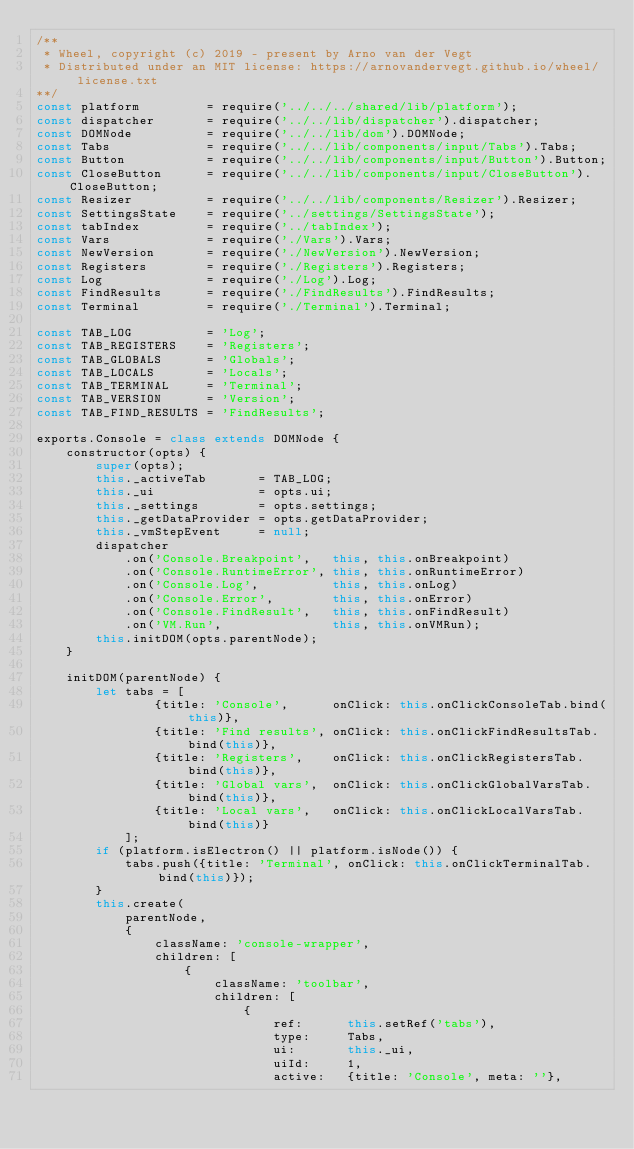<code> <loc_0><loc_0><loc_500><loc_500><_JavaScript_>/**
 * Wheel, copyright (c) 2019 - present by Arno van der Vegt
 * Distributed under an MIT license: https://arnovandervegt.github.io/wheel/license.txt
**/
const platform         = require('../../../shared/lib/platform');
const dispatcher       = require('../../lib/dispatcher').dispatcher;
const DOMNode          = require('../../lib/dom').DOMNode;
const Tabs             = require('../../lib/components/input/Tabs').Tabs;
const Button           = require('../../lib/components/input/Button').Button;
const CloseButton      = require('../../lib/components/input/CloseButton').CloseButton;
const Resizer          = require('../../lib/components/Resizer').Resizer;
const SettingsState    = require('../settings/SettingsState');
const tabIndex         = require('../tabIndex');
const Vars             = require('./Vars').Vars;
const NewVersion       = require('./NewVersion').NewVersion;
const Registers        = require('./Registers').Registers;
const Log              = require('./Log').Log;
const FindResults      = require('./FindResults').FindResults;
const Terminal         = require('./Terminal').Terminal;

const TAB_LOG          = 'Log';
const TAB_REGISTERS    = 'Registers';
const TAB_GLOBALS      = 'Globals';
const TAB_LOCALS       = 'Locals';
const TAB_TERMINAL     = 'Terminal';
const TAB_VERSION      = 'Version';
const TAB_FIND_RESULTS = 'FindResults';

exports.Console = class extends DOMNode {
    constructor(opts) {
        super(opts);
        this._activeTab       = TAB_LOG;
        this._ui              = opts.ui;
        this._settings        = opts.settings;
        this._getDataProvider = opts.getDataProvider;
        this._vmStepEvent     = null;
        dispatcher
            .on('Console.Breakpoint',   this, this.onBreakpoint)
            .on('Console.RuntimeError', this, this.onRuntimeError)
            .on('Console.Log',          this, this.onLog)
            .on('Console.Error',        this, this.onError)
            .on('Console.FindResult',   this, this.onFindResult)
            .on('VM.Run',               this, this.onVMRun);
        this.initDOM(opts.parentNode);
    }

    initDOM(parentNode) {
        let tabs = [
                {title: 'Console',      onClick: this.onClickConsoleTab.bind(this)},
                {title: 'Find results', onClick: this.onClickFindResultsTab.bind(this)},
                {title: 'Registers',    onClick: this.onClickRegistersTab.bind(this)},
                {title: 'Global vars',  onClick: this.onClickGlobalVarsTab.bind(this)},
                {title: 'Local vars',   onClick: this.onClickLocalVarsTab.bind(this)}
            ];
        if (platform.isElectron() || platform.isNode()) {
            tabs.push({title: 'Terminal', onClick: this.onClickTerminalTab.bind(this)});
        }
        this.create(
            parentNode,
            {
                className: 'console-wrapper',
                children: [
                    {
                        className: 'toolbar',
                        children: [
                            {
                                ref:      this.setRef('tabs'),
                                type:     Tabs,
                                ui:       this._ui,
                                uiId:     1,
                                active:   {title: 'Console', meta: ''},</code> 